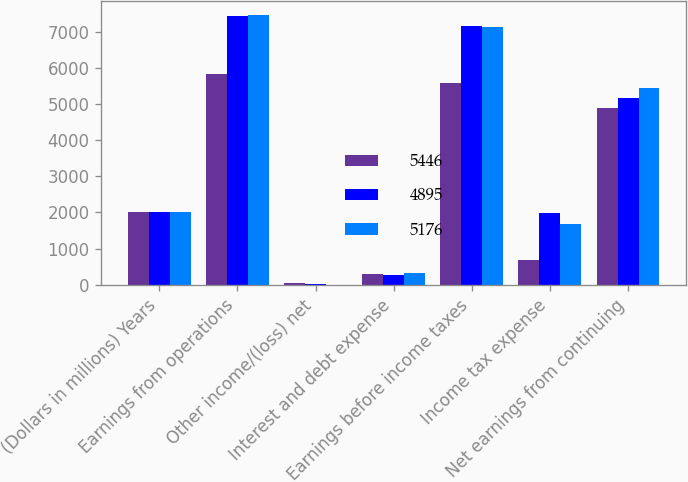<chart> <loc_0><loc_0><loc_500><loc_500><stacked_bar_chart><ecel><fcel>(Dollars in millions) Years<fcel>Earnings from operations<fcel>Other income/(loss) net<fcel>Interest and debt expense<fcel>Earnings before income taxes<fcel>Income tax expense<fcel>Net earnings from continuing<nl><fcel>5446<fcel>2016<fcel>5834<fcel>40<fcel>306<fcel>5568<fcel>673<fcel>4895<nl><fcel>4895<fcel>2015<fcel>7443<fcel>13<fcel>275<fcel>7155<fcel>1979<fcel>5176<nl><fcel>5176<fcel>2014<fcel>7473<fcel>3<fcel>333<fcel>7137<fcel>1691<fcel>5446<nl></chart> 